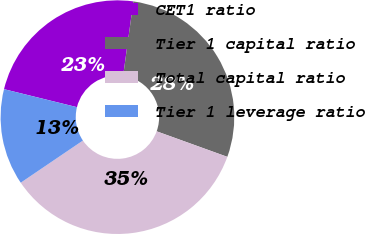Convert chart. <chart><loc_0><loc_0><loc_500><loc_500><pie_chart><fcel>CET1 ratio<fcel>Tier 1 capital ratio<fcel>Total capital ratio<fcel>Tier 1 leverage ratio<nl><fcel>23.33%<fcel>28.33%<fcel>35.0%<fcel>13.33%<nl></chart> 